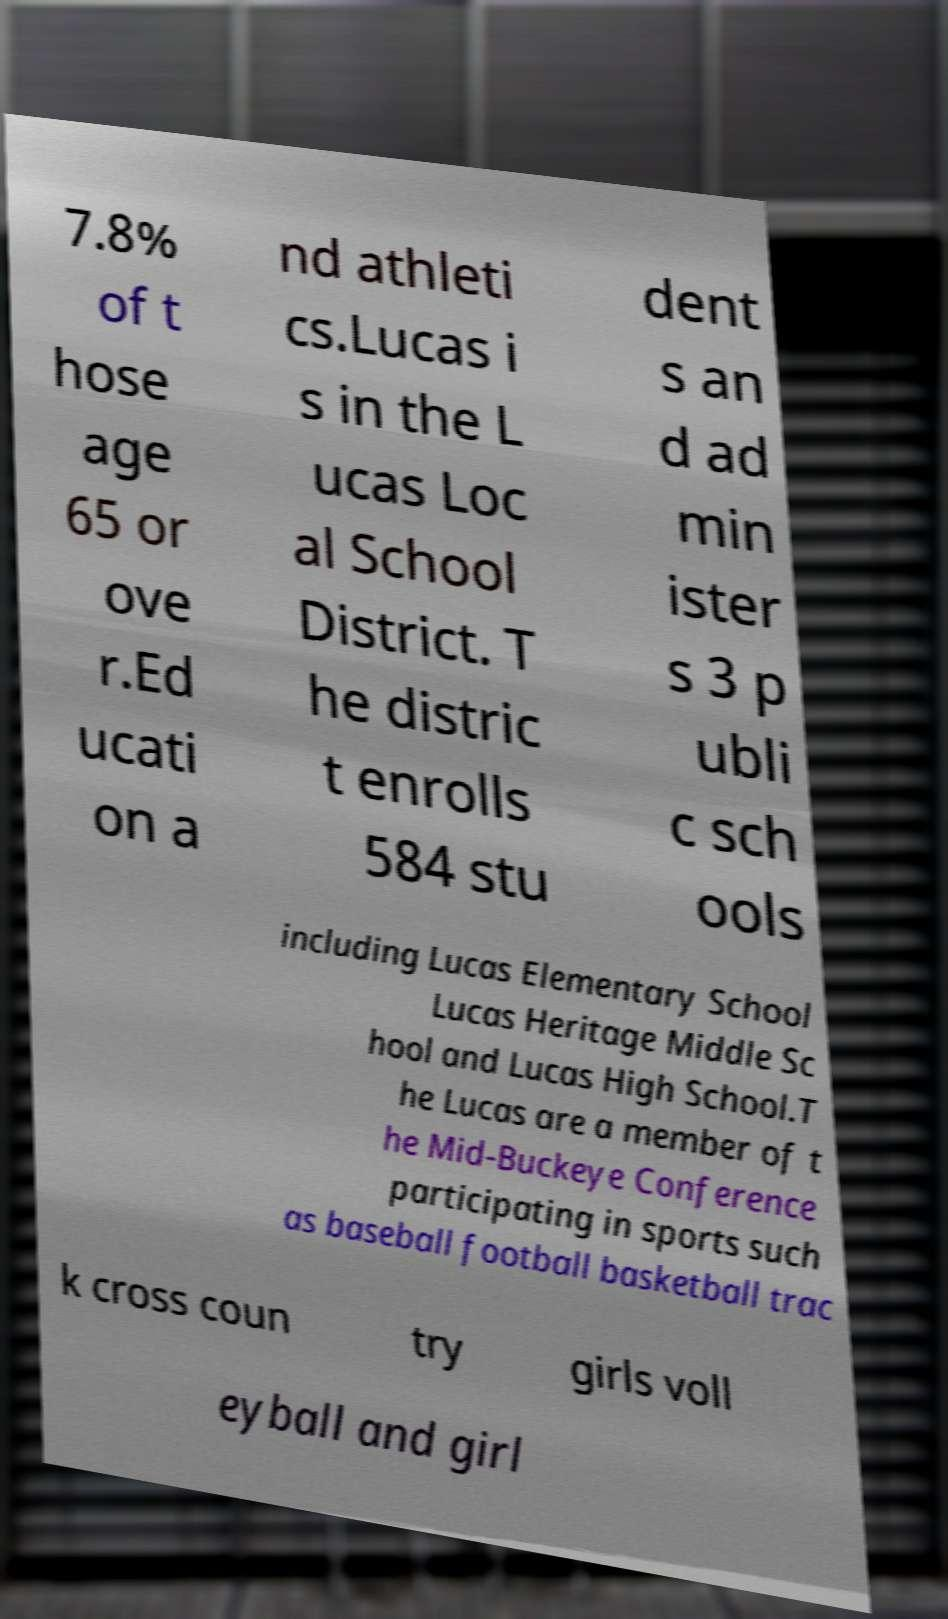Could you extract and type out the text from this image? 7.8% of t hose age 65 or ove r.Ed ucati on a nd athleti cs.Lucas i s in the L ucas Loc al School District. T he distric t enrolls 584 stu dent s an d ad min ister s 3 p ubli c sch ools including Lucas Elementary School Lucas Heritage Middle Sc hool and Lucas High School.T he Lucas are a member of t he Mid-Buckeye Conference participating in sports such as baseball football basketball trac k cross coun try girls voll eyball and girl 